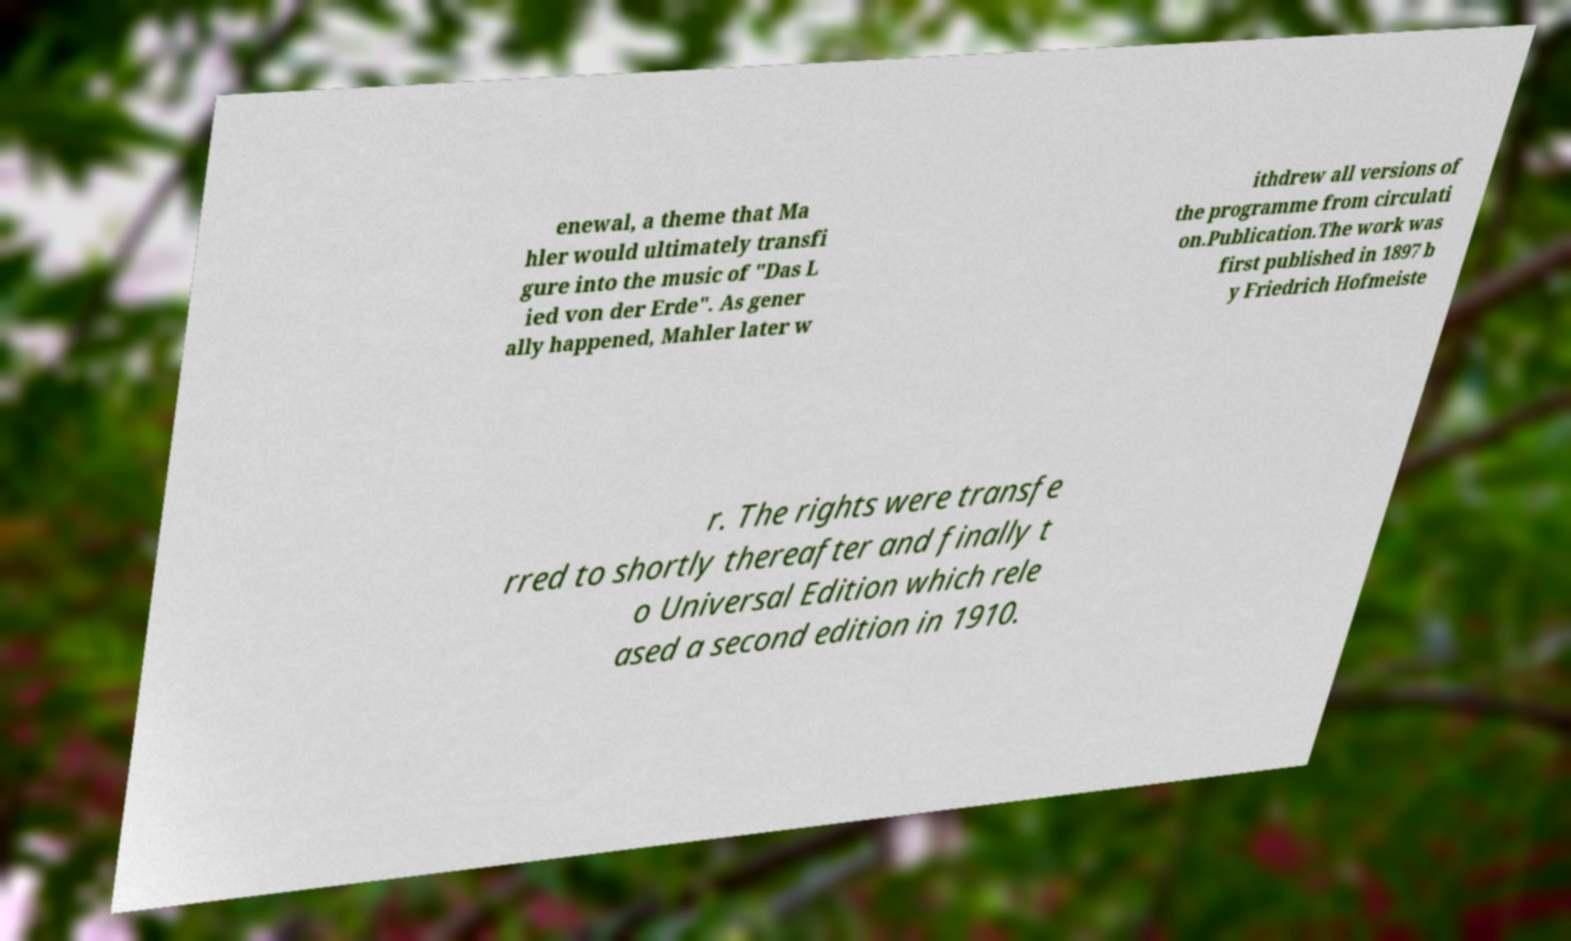What messages or text are displayed in this image? I need them in a readable, typed format. enewal, a theme that Ma hler would ultimately transfi gure into the music of "Das L ied von der Erde". As gener ally happened, Mahler later w ithdrew all versions of the programme from circulati on.Publication.The work was first published in 1897 b y Friedrich Hofmeiste r. The rights were transfe rred to shortly thereafter and finally t o Universal Edition which rele ased a second edition in 1910. 